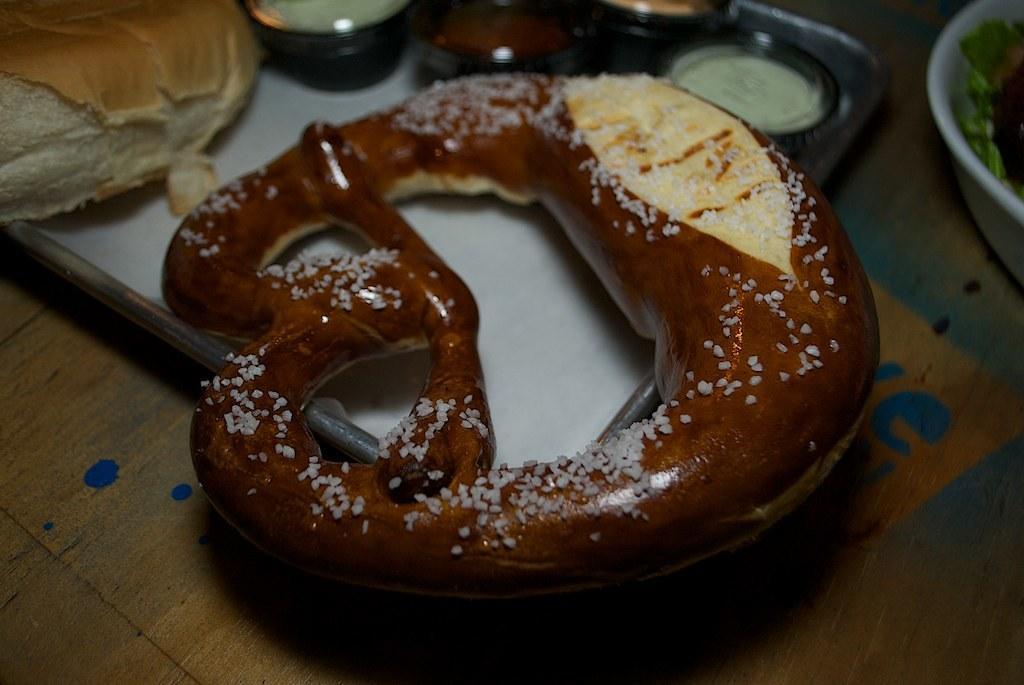Could you give a brief overview of what you see in this image? In the foreground of this image, there is a lye roll in the plate. On right, there is a bowl. On left there is a bread in plate. On top there is a few bowls. 